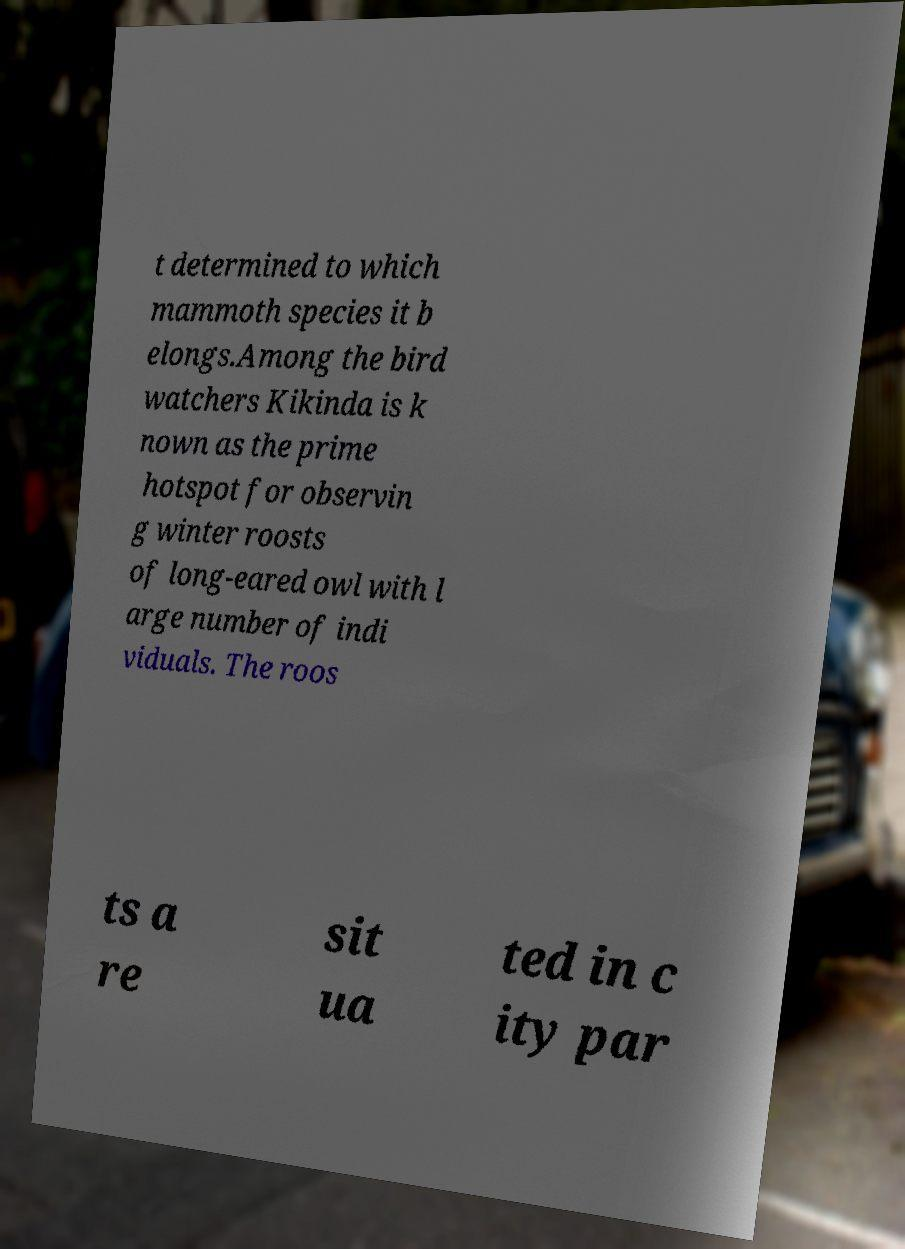Could you extract and type out the text from this image? t determined to which mammoth species it b elongs.Among the bird watchers Kikinda is k nown as the prime hotspot for observin g winter roosts of long-eared owl with l arge number of indi viduals. The roos ts a re sit ua ted in c ity par 